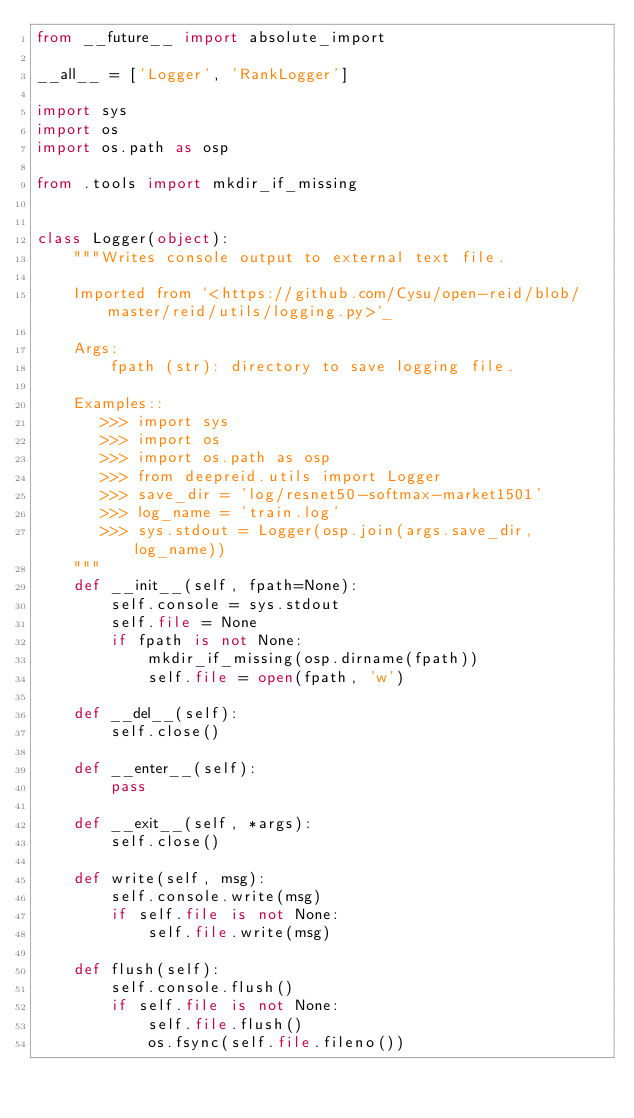<code> <loc_0><loc_0><loc_500><loc_500><_Python_>from __future__ import absolute_import

__all__ = ['Logger', 'RankLogger']

import sys
import os
import os.path as osp

from .tools import mkdir_if_missing


class Logger(object):
    """Writes console output to external text file.

    Imported from `<https://github.com/Cysu/open-reid/blob/master/reid/utils/logging.py>`_

    Args:
        fpath (str): directory to save logging file.

    Examples::
       >>> import sys
       >>> import os
       >>> import os.path as osp
       >>> from deepreid.utils import Logger
       >>> save_dir = 'log/resnet50-softmax-market1501'
       >>> log_name = 'train.log'
       >>> sys.stdout = Logger(osp.join(args.save_dir, log_name))
    """  
    def __init__(self, fpath=None):
        self.console = sys.stdout
        self.file = None
        if fpath is not None:
            mkdir_if_missing(osp.dirname(fpath))
            self.file = open(fpath, 'w')

    def __del__(self):
        self.close()

    def __enter__(self):
        pass

    def __exit__(self, *args):
        self.close()

    def write(self, msg):
        self.console.write(msg)
        if self.file is not None:
            self.file.write(msg)

    def flush(self):
        self.console.flush()
        if self.file is not None:
            self.file.flush()
            os.fsync(self.file.fileno())
</code> 